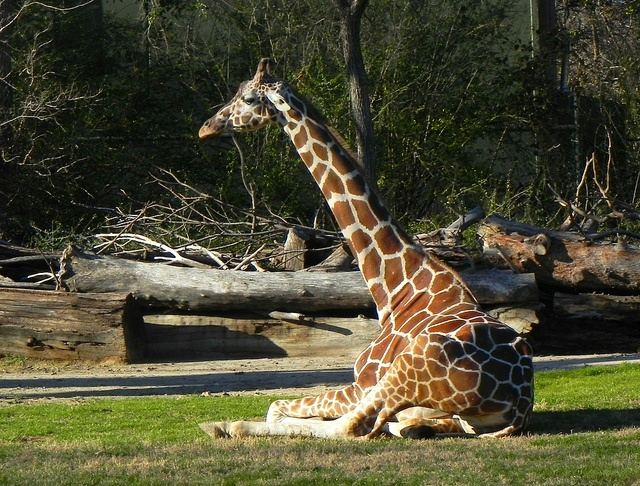Describe the objects in this image and their specific colors. I can see a giraffe in black, brown, beige, and maroon tones in this image. 